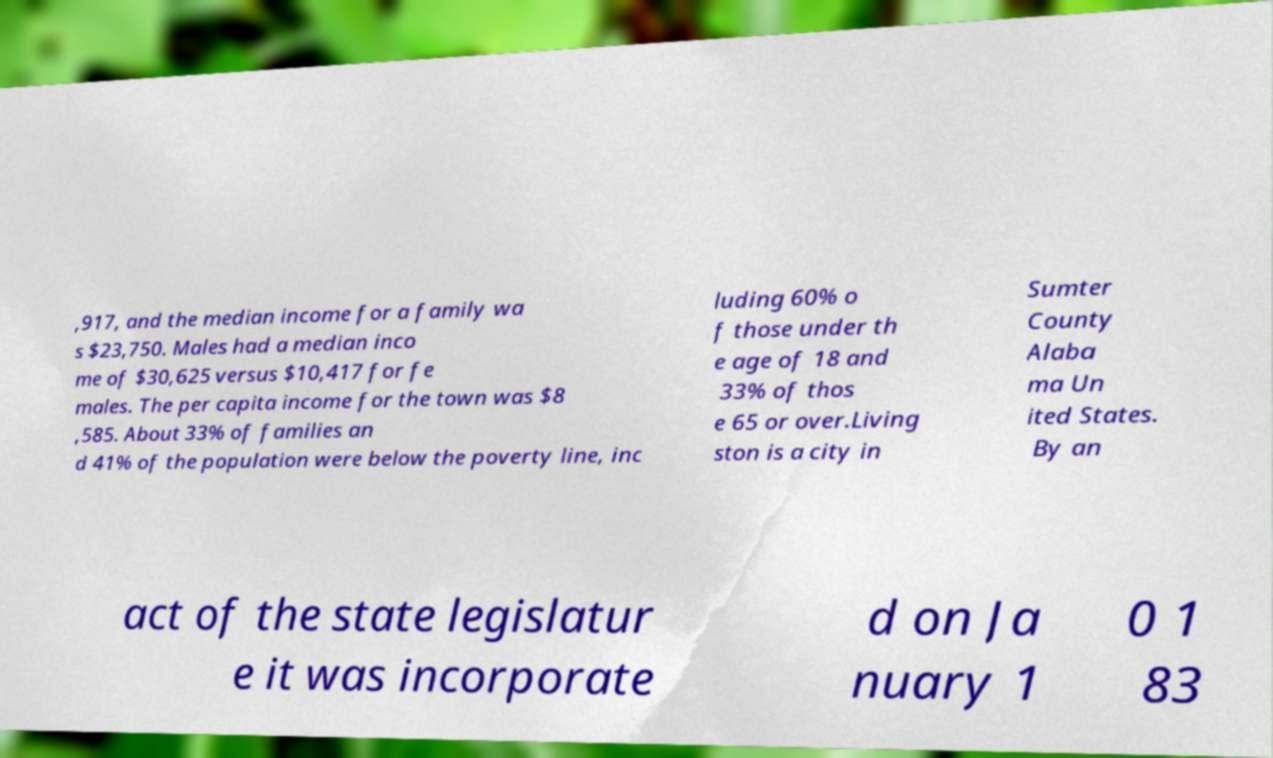For documentation purposes, I need the text within this image transcribed. Could you provide that? ,917, and the median income for a family wa s $23,750. Males had a median inco me of $30,625 versus $10,417 for fe males. The per capita income for the town was $8 ,585. About 33% of families an d 41% of the population were below the poverty line, inc luding 60% o f those under th e age of 18 and 33% of thos e 65 or over.Living ston is a city in Sumter County Alaba ma Un ited States. By an act of the state legislatur e it was incorporate d on Ja nuary 1 0 1 83 